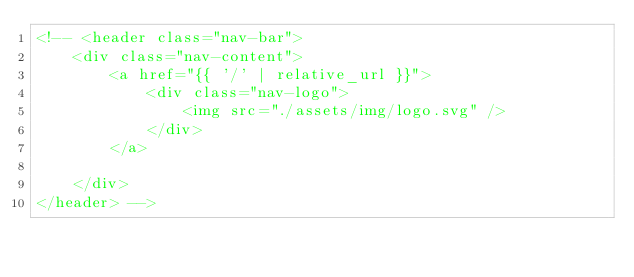<code> <loc_0><loc_0><loc_500><loc_500><_HTML_><!-- <header class="nav-bar">
    <div class="nav-content">
        <a href="{{ '/' | relative_url }}">
            <div class="nav-logo">
                <img src="./assets/img/logo.svg" />
            </div>
        </a>

    </div>
</header> -->
</code> 